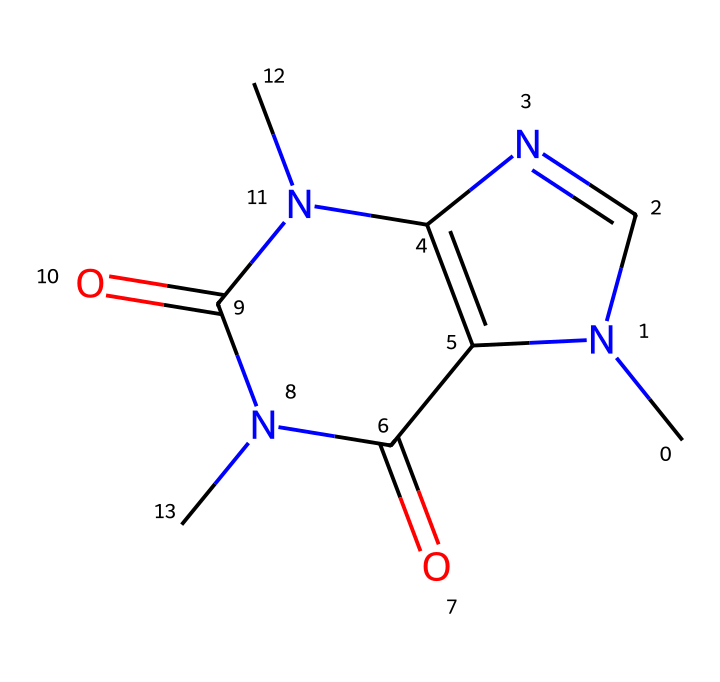What is the molecular formula of this compound? To determine the molecular formula, count the number of each type of atom present in the chemical structure. In the SMILES representation, we can see there are 8 carbons (C), 10 hydrogens (H), 4 nitrogens (N), and 2 oxygens (O), leading to the molecular formula C8H10N4O2.
Answer: C8H10N4O2 How many nitrogen atoms are in the chemical structure? By analyzing the SMILES notation, we find that there are 4 instances of nitrogen (N) present, which are clearly indicated in the sequence.
Answer: 4 Is caffeine a polar or non-polar molecule? Caffeine contains polar functional groups, specifically the nitrogen and oxygen atoms, which influences its overall polarity; however, the large carbon backbone tends to make it more non-polar overall. It is generally classified as a non-polar molecule due to the balance of polar and non-polar elements.
Answer: non-polar Which functional groups are present in caffeine? In the SMILES representation, we identify amine (due to nitrogen atoms), carbonyl (due to the C=O), and imine functional groups. Together, these help define caffeine’s chemical properties.
Answer: amine, carbonyl, imine What type of bonding is primarily involved in caffeine's structure? In caffeine's structure, the predominant types of bonding include covalent bonds between carbon, hydrogen, oxygen, and nitrogen atoms; these bonds create the stable framework for the molecule.
Answer: covalent What is the pKa of caffeine? Caffeine is a weak base and typically has a pKa value around 10.4, making it a relatively weak acid component when considering interactions in solution.
Answer: 10.4 